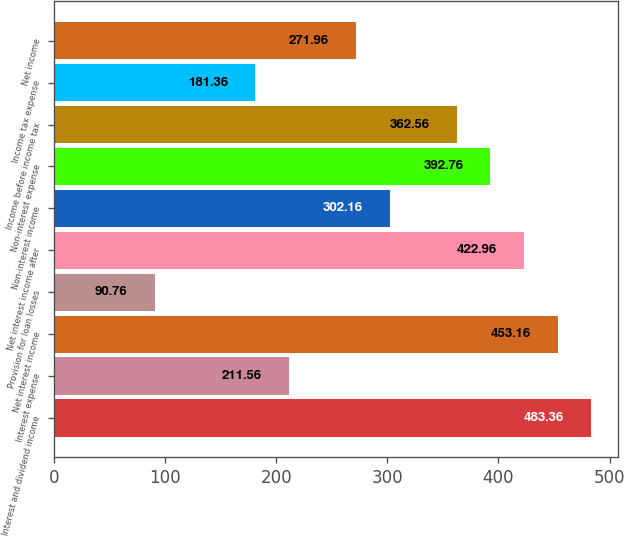Convert chart. <chart><loc_0><loc_0><loc_500><loc_500><bar_chart><fcel>Interest and dividend income<fcel>Interest expense<fcel>Net interest income<fcel>Provision for loan losses<fcel>Net interest income after<fcel>Non-interest income<fcel>Non-interest expense<fcel>Income before income tax<fcel>Income tax expense<fcel>Net income<nl><fcel>483.36<fcel>211.56<fcel>453.16<fcel>90.76<fcel>422.96<fcel>302.16<fcel>392.76<fcel>362.56<fcel>181.36<fcel>271.96<nl></chart> 